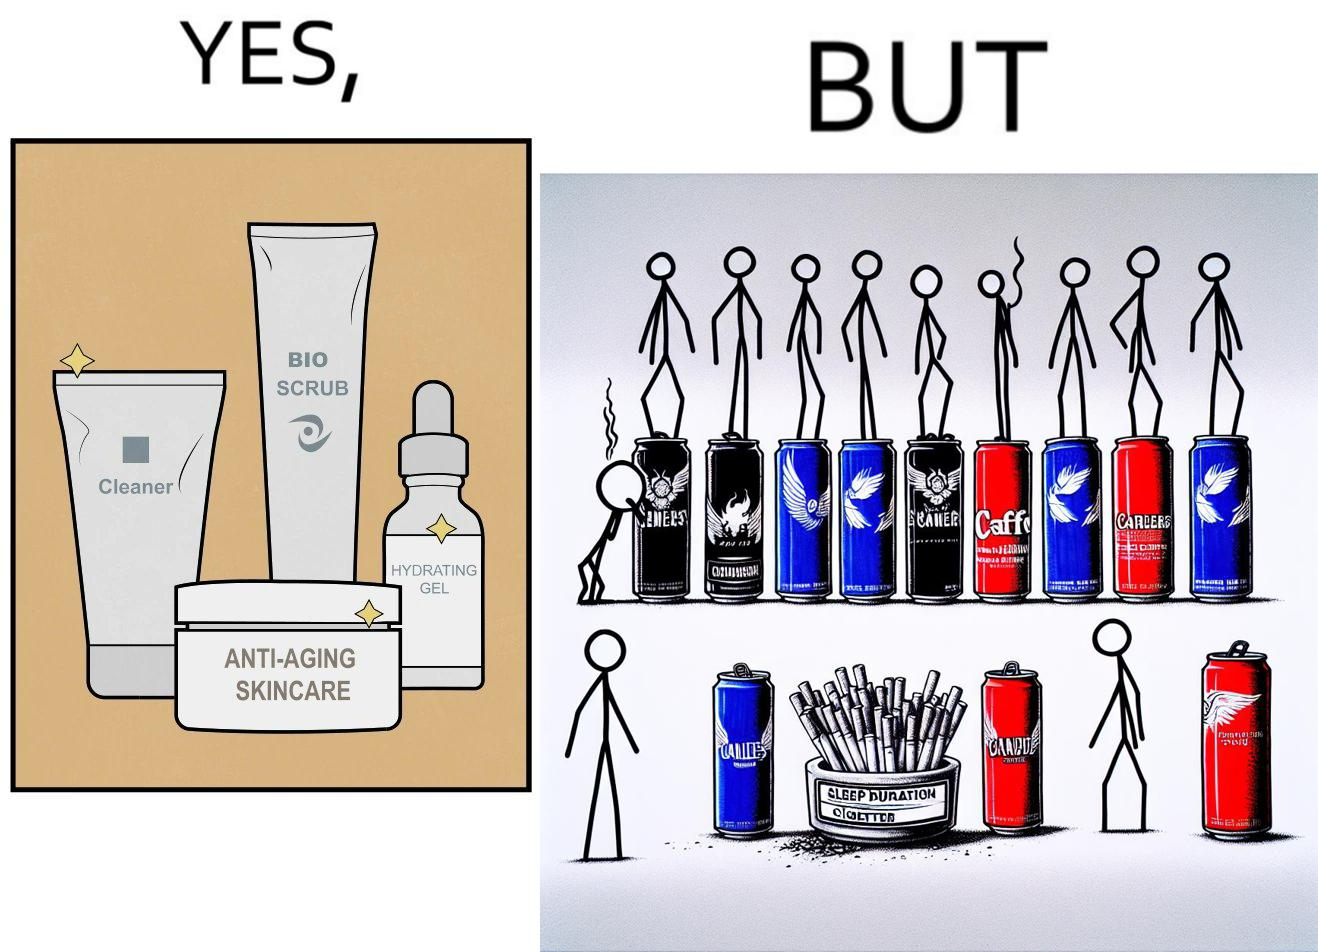Compare the left and right sides of this image. In the left part of the image: 4 Skincare products, arranged aesthetically. A tube labeled "Cleaner". A tube labeled "BIO SCRUB". A dropper bottle labeled "HYDRATING GEL". A jar called "ANTI-AGING SKINCARE". In the right part of the image: 9 cans of red bull, some standing upright, some crushed. Cans have blue and red colors. An ashtray with many cigarette butts in it and has smoke coming out. A banner that says "Sleep duration 2h 5min". 